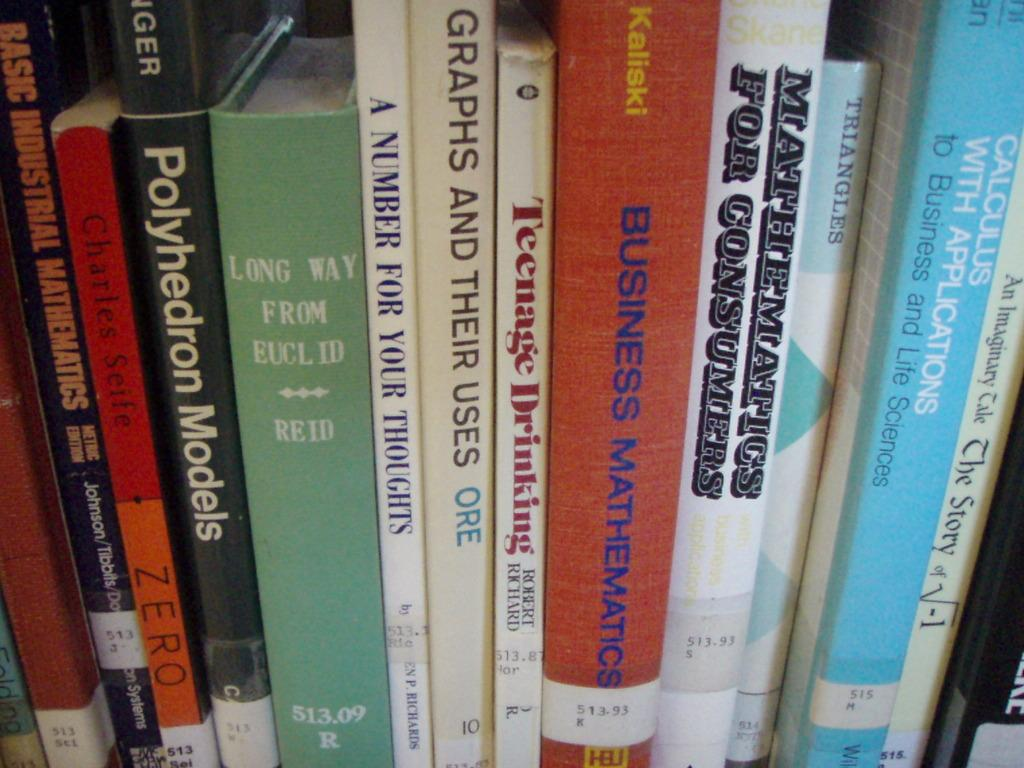<image>
Offer a succinct explanation of the picture presented. A row of books covers topics like mathematics and business. 